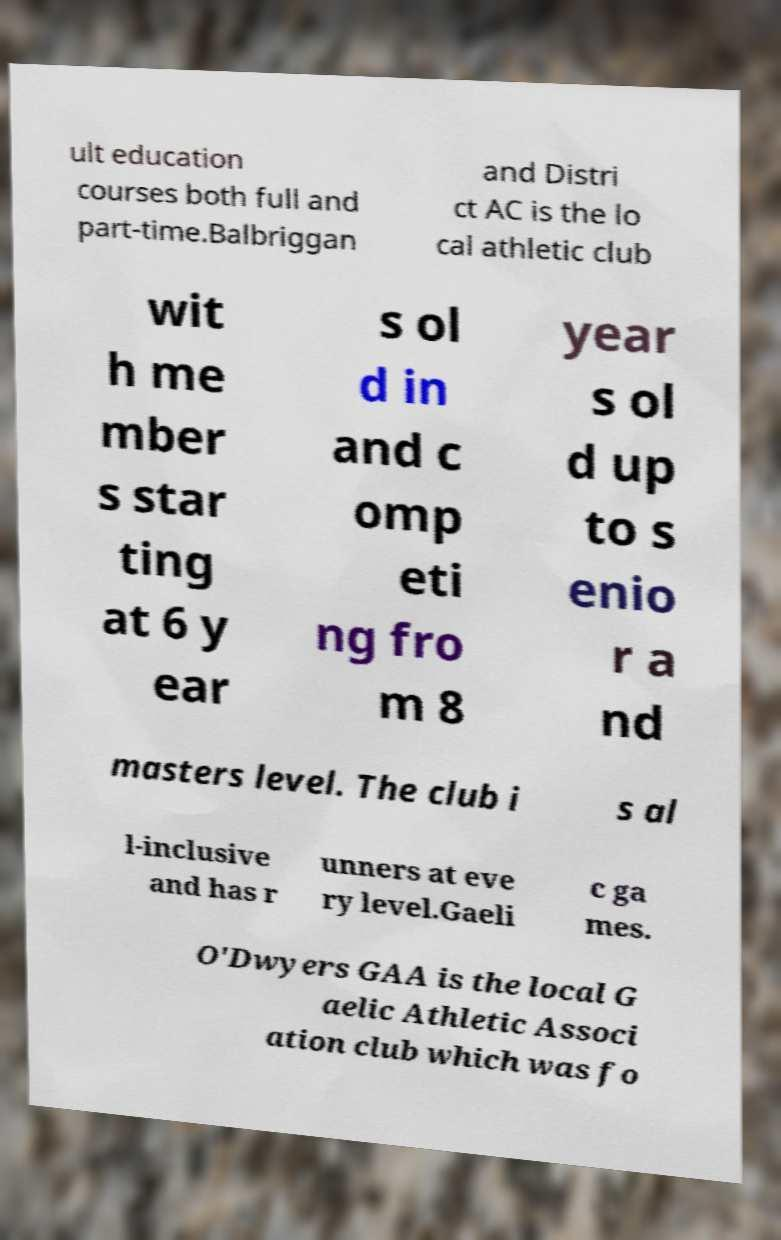There's text embedded in this image that I need extracted. Can you transcribe it verbatim? ult education courses both full and part-time.Balbriggan and Distri ct AC is the lo cal athletic club wit h me mber s star ting at 6 y ear s ol d in and c omp eti ng fro m 8 year s ol d up to s enio r a nd masters level. The club i s al l-inclusive and has r unners at eve ry level.Gaeli c ga mes. O'Dwyers GAA is the local G aelic Athletic Associ ation club which was fo 